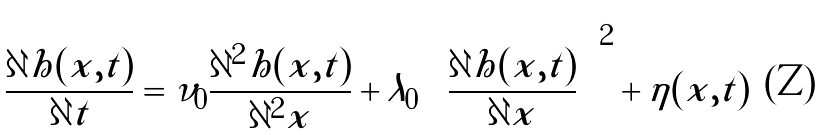<formula> <loc_0><loc_0><loc_500><loc_500>\frac { \partial h ( x , t ) } { \partial t } = \nu _ { 0 } \frac { \partial ^ { 2 } h ( x , t ) } { \partial ^ { 2 } x } + \lambda _ { 0 } \left ( \frac { \partial h ( x , t ) } { \partial x } \right ) ^ { 2 } + \eta ( x , t )</formula> 